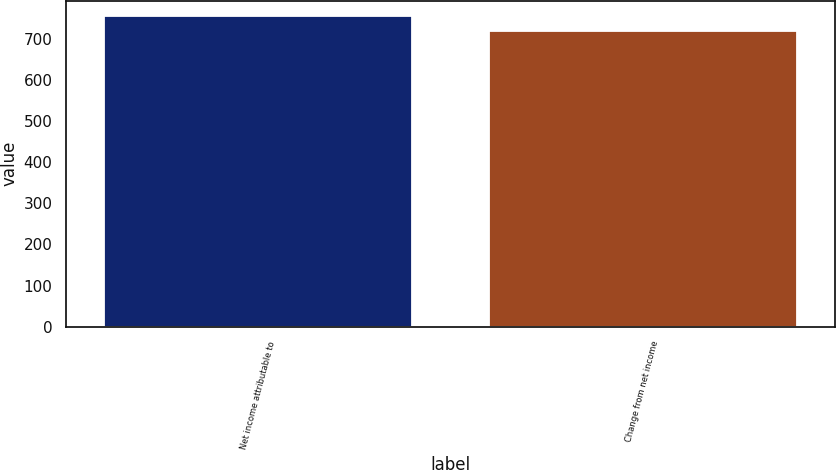Convert chart. <chart><loc_0><loc_0><loc_500><loc_500><bar_chart><fcel>Net income attributable to<fcel>Change from net income<nl><fcel>755<fcel>720<nl></chart> 